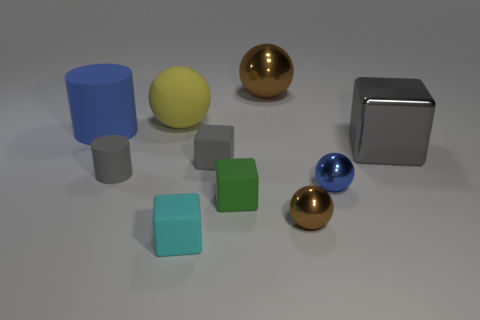Subtract all spheres. How many objects are left? 6 Subtract all green matte things. Subtract all large yellow rubber objects. How many objects are left? 8 Add 8 small brown spheres. How many small brown spheres are left? 9 Add 9 gray rubber cubes. How many gray rubber cubes exist? 10 Subtract 0 yellow cylinders. How many objects are left? 10 